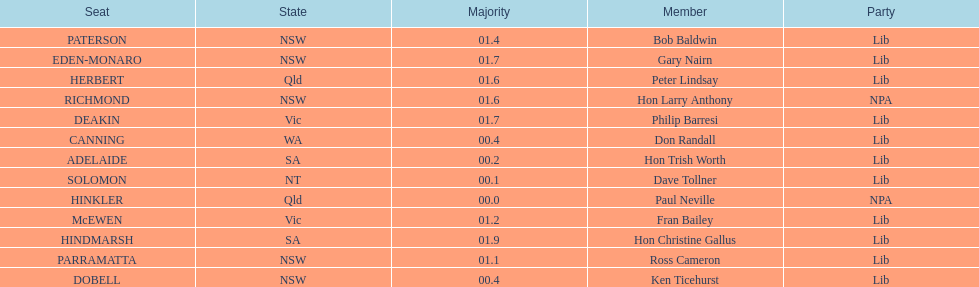What is the total of seats? 13. 